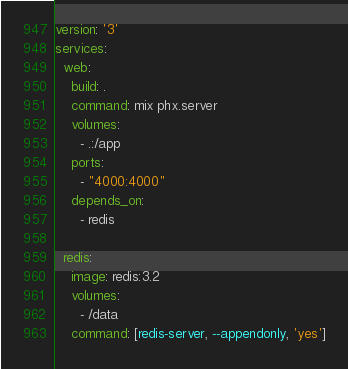<code> <loc_0><loc_0><loc_500><loc_500><_YAML_>version: '3'
services:
  web:
    build: .
    command: mix phx.server
    volumes:
      - .:/app
    ports:
      - "4000:4000"
    depends_on:
      - redis

  redis:
    image: redis:3.2
    volumes:
      - /data
    command: [redis-server, --appendonly, 'yes']
</code> 